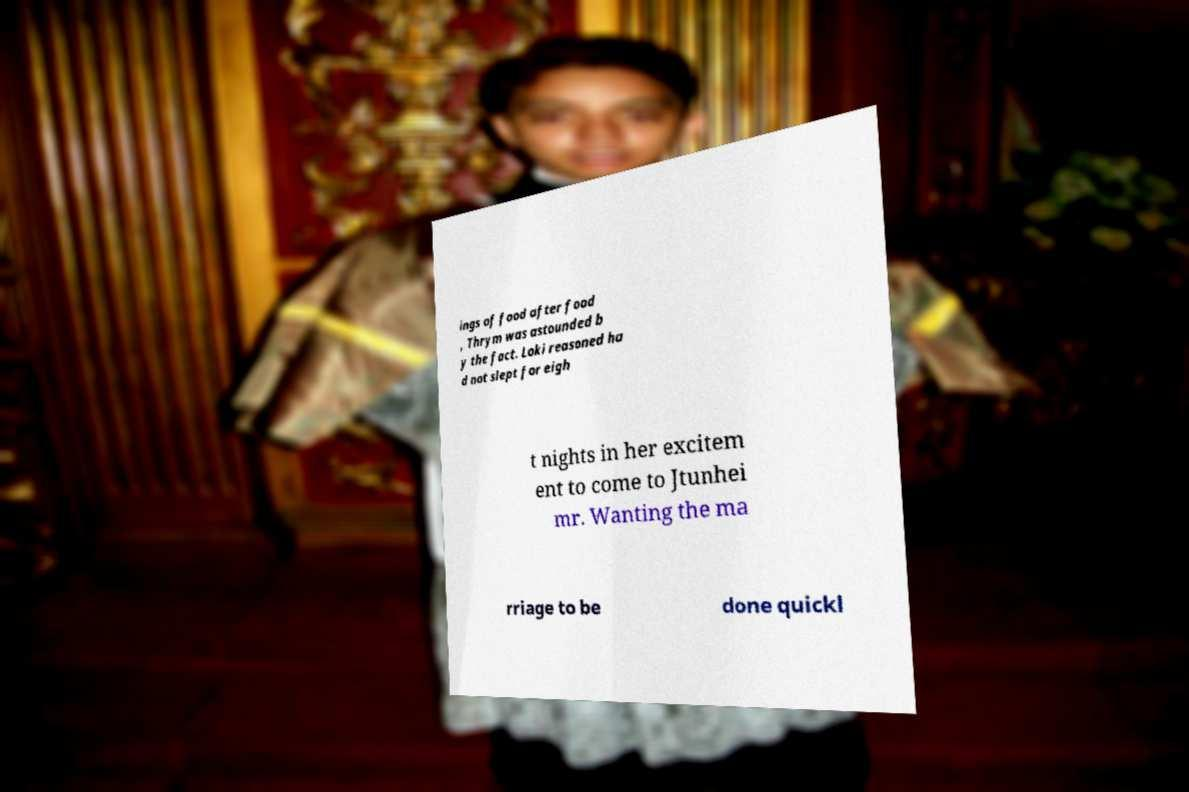There's text embedded in this image that I need extracted. Can you transcribe it verbatim? ings of food after food , Thrym was astounded b y the fact. Loki reasoned ha d not slept for eigh t nights in her excitem ent to come to Jtunhei mr. Wanting the ma rriage to be done quickl 